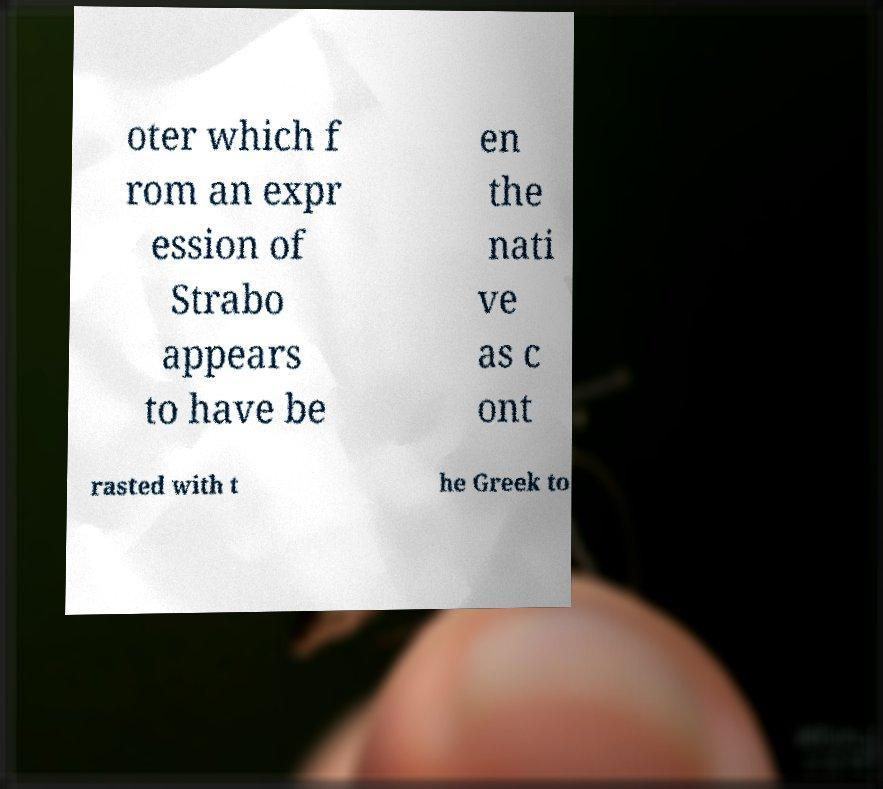Could you assist in decoding the text presented in this image and type it out clearly? oter which f rom an expr ession of Strabo appears to have be en the nati ve as c ont rasted with t he Greek to 